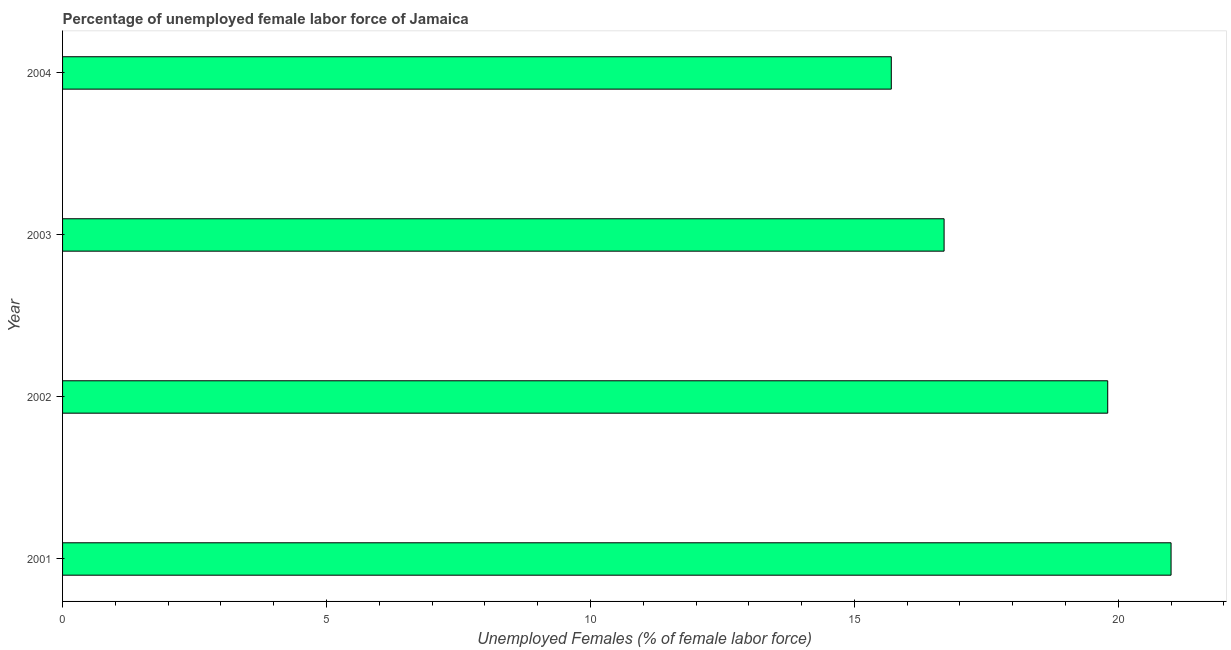Does the graph contain any zero values?
Provide a succinct answer. No. Does the graph contain grids?
Offer a terse response. No. What is the title of the graph?
Ensure brevity in your answer.  Percentage of unemployed female labor force of Jamaica. What is the label or title of the X-axis?
Your response must be concise. Unemployed Females (% of female labor force). What is the total unemployed female labour force in 2002?
Give a very brief answer. 19.8. Across all years, what is the maximum total unemployed female labour force?
Provide a short and direct response. 21. Across all years, what is the minimum total unemployed female labour force?
Your answer should be compact. 15.7. What is the sum of the total unemployed female labour force?
Your answer should be very brief. 73.2. What is the median total unemployed female labour force?
Your answer should be very brief. 18.25. In how many years, is the total unemployed female labour force greater than 16 %?
Offer a very short reply. 3. What is the ratio of the total unemployed female labour force in 2001 to that in 2002?
Provide a succinct answer. 1.06. What is the difference between the highest and the lowest total unemployed female labour force?
Keep it short and to the point. 5.3. How many bars are there?
Your response must be concise. 4. How many years are there in the graph?
Offer a terse response. 4. What is the difference between two consecutive major ticks on the X-axis?
Your answer should be very brief. 5. What is the Unemployed Females (% of female labor force) in 2001?
Your answer should be compact. 21. What is the Unemployed Females (% of female labor force) of 2002?
Your answer should be compact. 19.8. What is the Unemployed Females (% of female labor force) in 2003?
Offer a terse response. 16.7. What is the Unemployed Females (% of female labor force) of 2004?
Make the answer very short. 15.7. What is the difference between the Unemployed Females (% of female labor force) in 2001 and 2002?
Your answer should be compact. 1.2. What is the difference between the Unemployed Females (% of female labor force) in 2002 and 2004?
Ensure brevity in your answer.  4.1. What is the ratio of the Unemployed Females (% of female labor force) in 2001 to that in 2002?
Your answer should be very brief. 1.06. What is the ratio of the Unemployed Females (% of female labor force) in 2001 to that in 2003?
Make the answer very short. 1.26. What is the ratio of the Unemployed Females (% of female labor force) in 2001 to that in 2004?
Provide a short and direct response. 1.34. What is the ratio of the Unemployed Females (% of female labor force) in 2002 to that in 2003?
Give a very brief answer. 1.19. What is the ratio of the Unemployed Females (% of female labor force) in 2002 to that in 2004?
Give a very brief answer. 1.26. What is the ratio of the Unemployed Females (% of female labor force) in 2003 to that in 2004?
Make the answer very short. 1.06. 